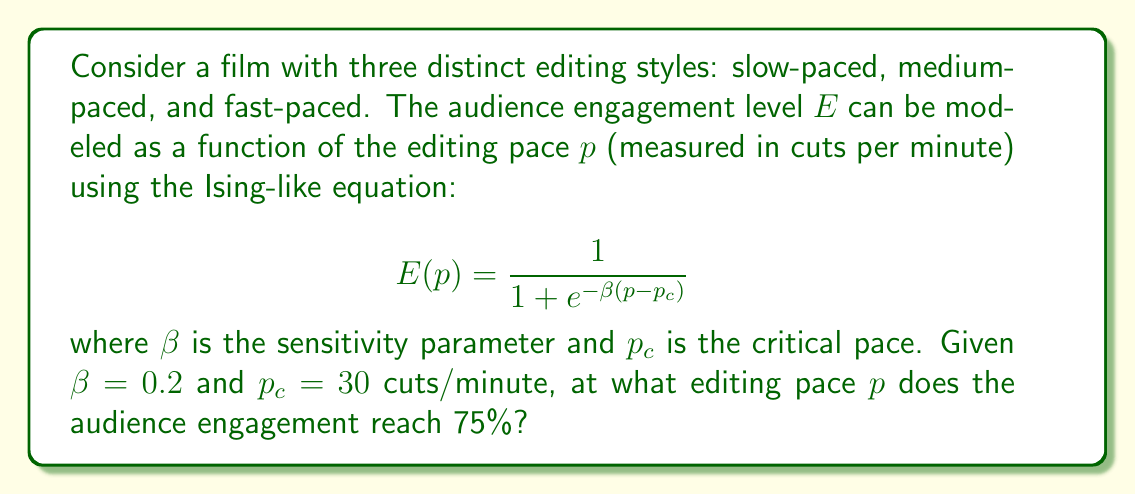Provide a solution to this math problem. To solve this problem, we'll follow these steps:

1) We're given the equation for audience engagement:
   $$E(p) = \frac{1}{1 + e^{-\beta(p-p_c)}}$$

2) We're also given that $\beta = 0.2$ and $p_c = 30$.

3) We want to find $p$ when $E(p) = 0.75$ or 75%.

4) Let's substitute these values into the equation:
   $$0.75 = \frac{1}{1 + e^{-0.2(p-30)}}$$

5) Now, let's solve this equation for $p$:
   
   $$0.75(1 + e^{-0.2(p-30)}) = 1$$
   
   $$1 + e^{-0.2(p-30)} = \frac{4}{3}$$
   
   $$e^{-0.2(p-30)} = \frac{1}{3}$$

6) Taking the natural log of both sides:
   
   $$-0.2(p-30) = \ln(\frac{1}{3})$$
   
   $$p-30 = -\frac{\ln(\frac{1}{3})}{0.2}$$
   
   $$p = 30 - \frac{\ln(\frac{1}{3})}{0.2}$$

7) Calculate the final value:
   $$p \approx 30 + 5.49 = 35.49$$

Therefore, the audience engagement reaches 75% at approximately 35.49 cuts per minute.
Answer: 35.49 cuts/minute 